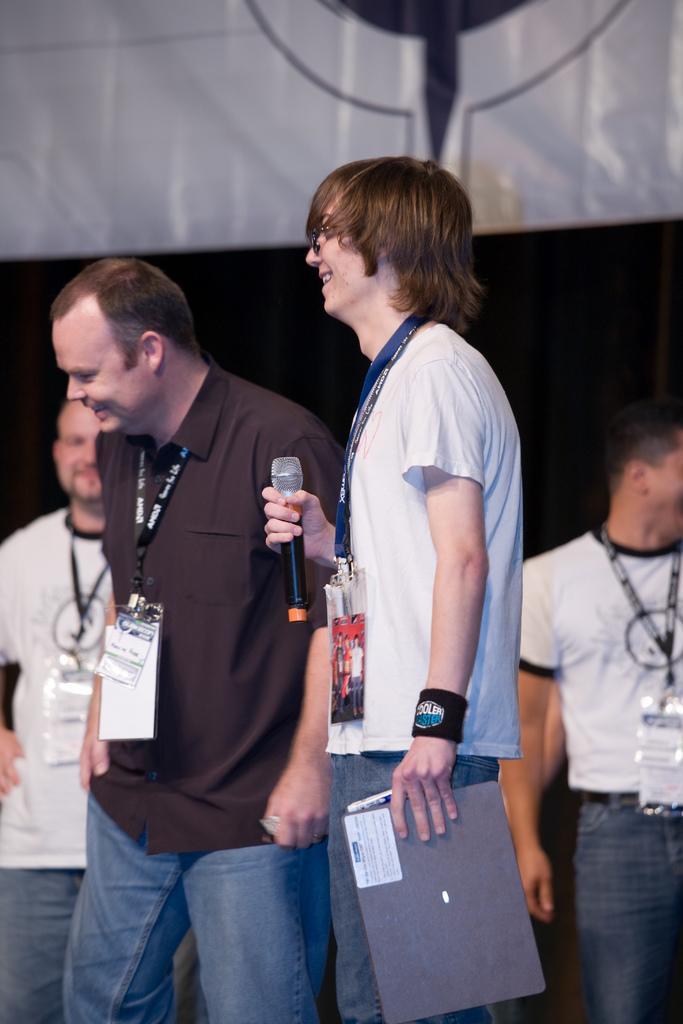Describe this image in one or two sentences. In this image I can see the group of people with different color dresses. I can see these people are wearing the identification cards and one person holding the mic and the grey color object. In the background I can see the banner. 